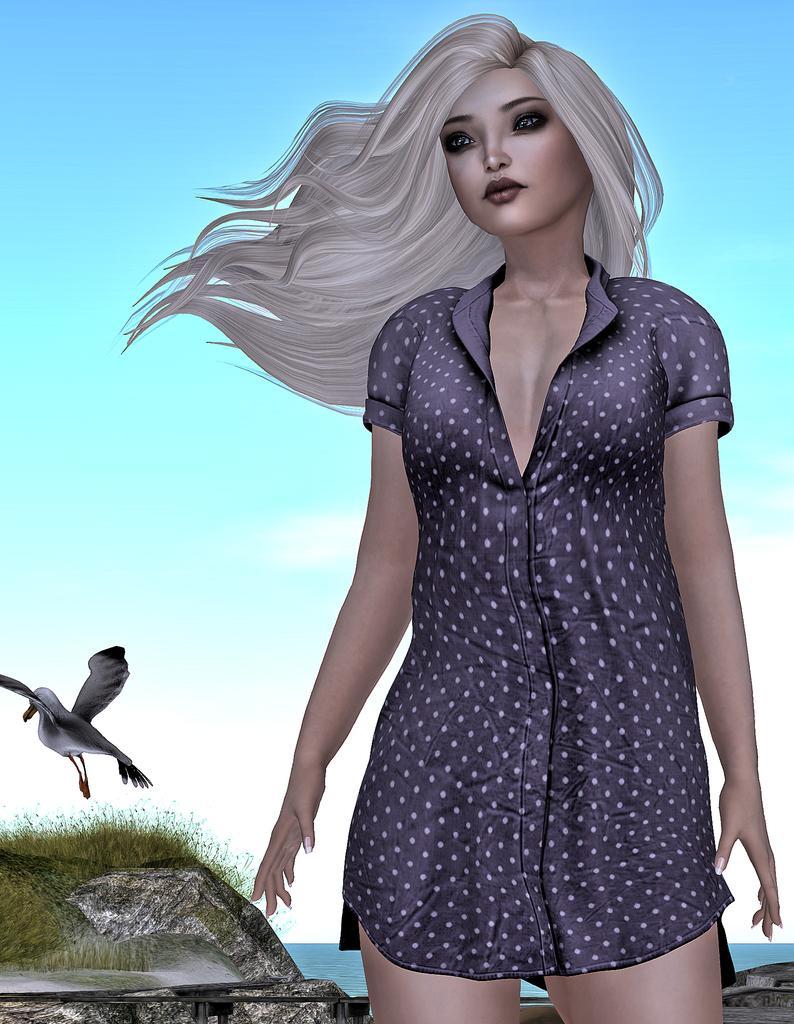Describe this image in one or two sentences. It is a graphical image, in the image we can see a woman, grass, bird, water and clouds and sky. 